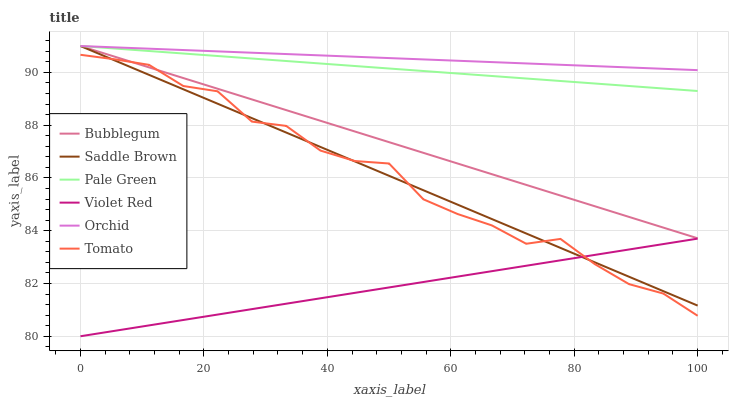Does Violet Red have the minimum area under the curve?
Answer yes or no. Yes. Does Orchid have the maximum area under the curve?
Answer yes or no. Yes. Does Bubblegum have the minimum area under the curve?
Answer yes or no. No. Does Bubblegum have the maximum area under the curve?
Answer yes or no. No. Is Orchid the smoothest?
Answer yes or no. Yes. Is Tomato the roughest?
Answer yes or no. Yes. Is Violet Red the smoothest?
Answer yes or no. No. Is Violet Red the roughest?
Answer yes or no. No. Does Violet Red have the lowest value?
Answer yes or no. Yes. Does Bubblegum have the lowest value?
Answer yes or no. No. Does Orchid have the highest value?
Answer yes or no. Yes. Does Violet Red have the highest value?
Answer yes or no. No. Is Violet Red less than Bubblegum?
Answer yes or no. Yes. Is Pale Green greater than Violet Red?
Answer yes or no. Yes. Does Orchid intersect Saddle Brown?
Answer yes or no. Yes. Is Orchid less than Saddle Brown?
Answer yes or no. No. Is Orchid greater than Saddle Brown?
Answer yes or no. No. Does Violet Red intersect Bubblegum?
Answer yes or no. No. 